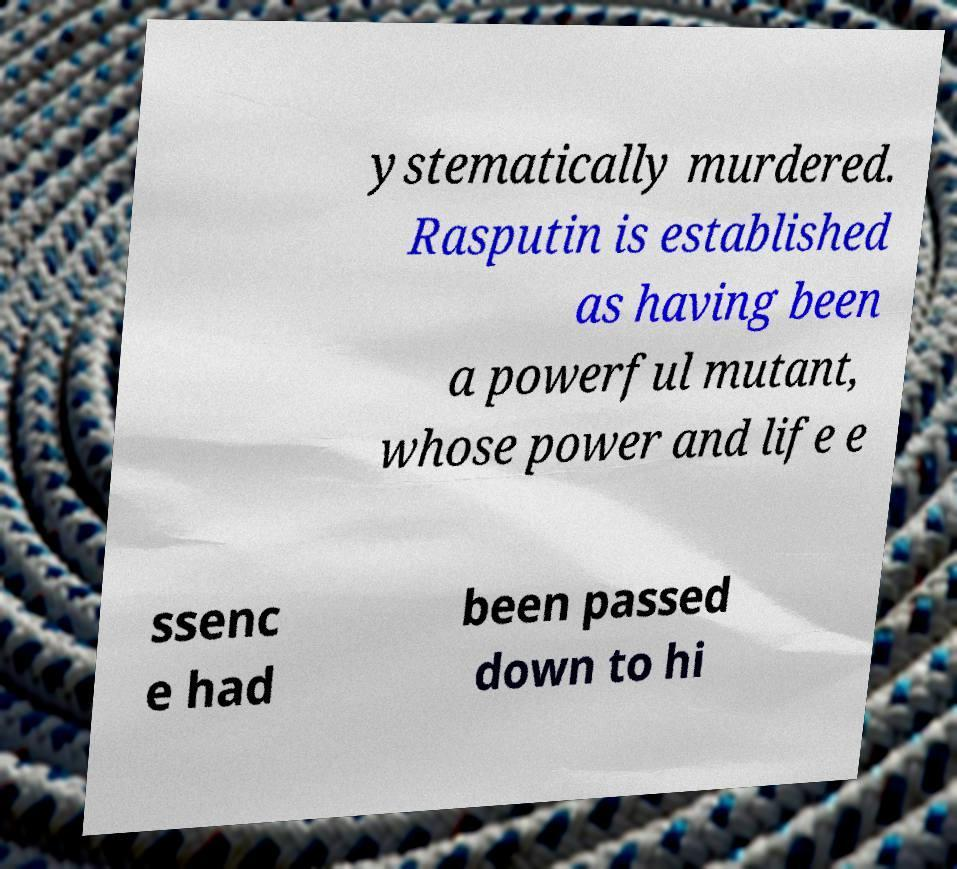Could you extract and type out the text from this image? ystematically murdered. Rasputin is established as having been a powerful mutant, whose power and life e ssenc e had been passed down to hi 